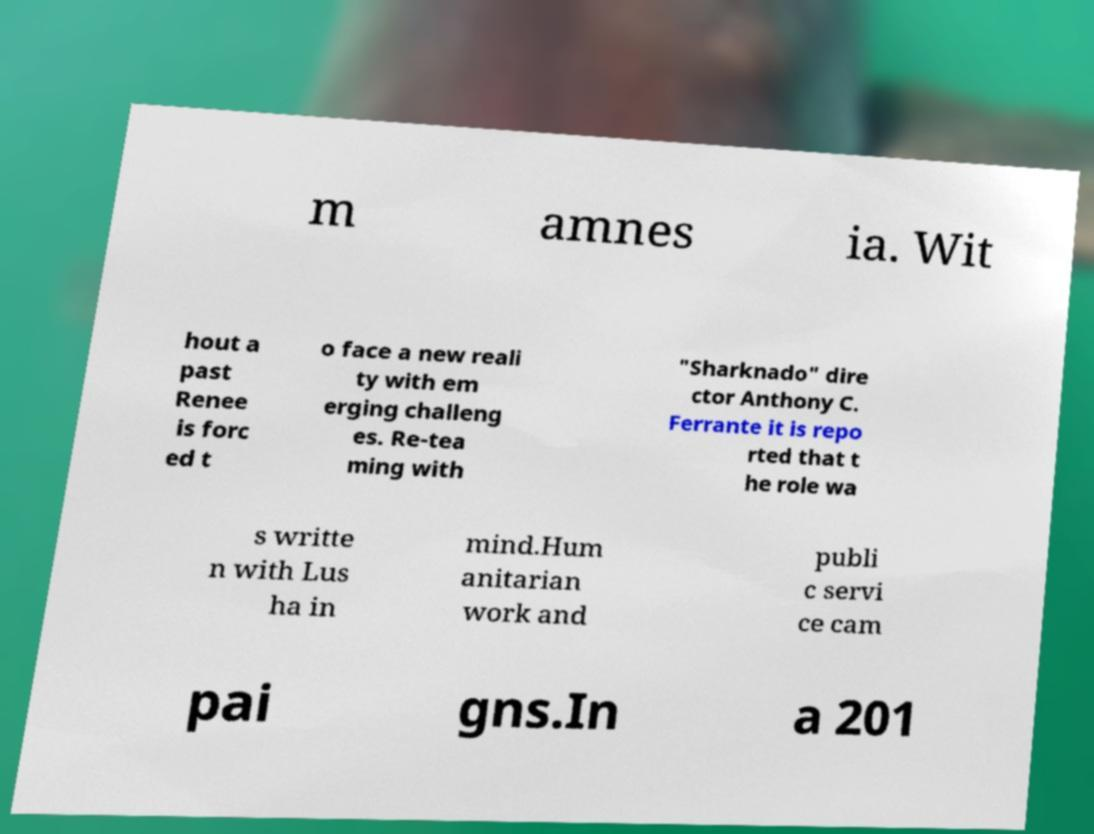I need the written content from this picture converted into text. Can you do that? m amnes ia. Wit hout a past Renee is forc ed t o face a new reali ty with em erging challeng es. Re-tea ming with "Sharknado" dire ctor Anthony C. Ferrante it is repo rted that t he role wa s writte n with Lus ha in mind.Hum anitarian work and publi c servi ce cam pai gns.In a 201 